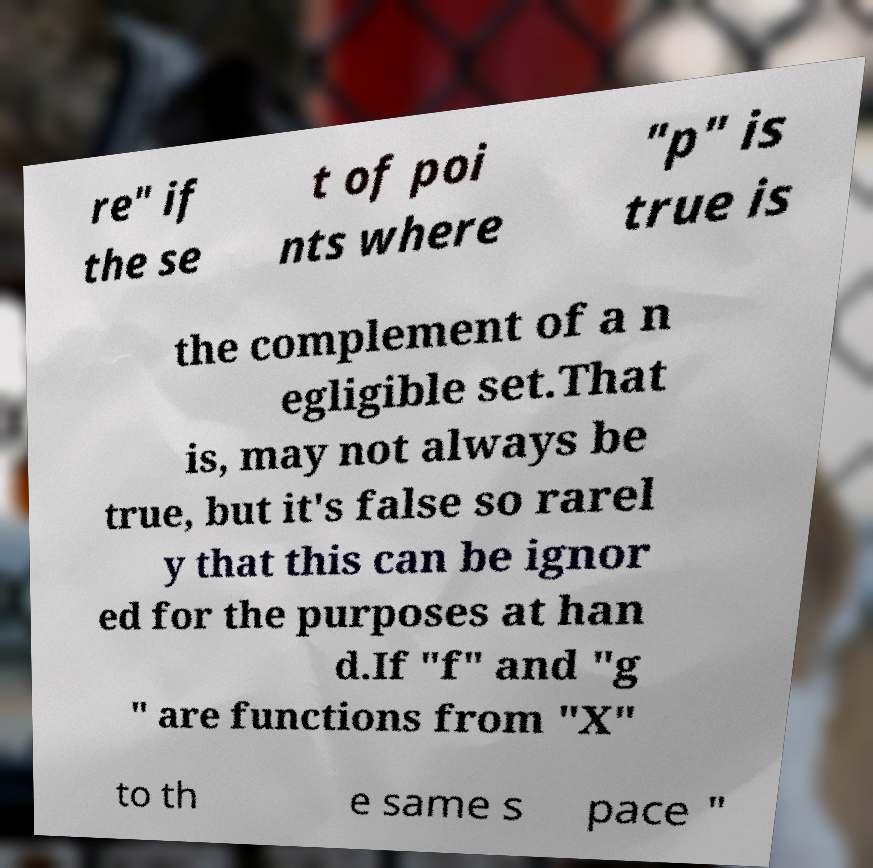Can you read and provide the text displayed in the image?This photo seems to have some interesting text. Can you extract and type it out for me? re" if the se t of poi nts where "p" is true is the complement of a n egligible set.That is, may not always be true, but it's false so rarel y that this can be ignor ed for the purposes at han d.If "f" and "g " are functions from "X" to th e same s pace " 